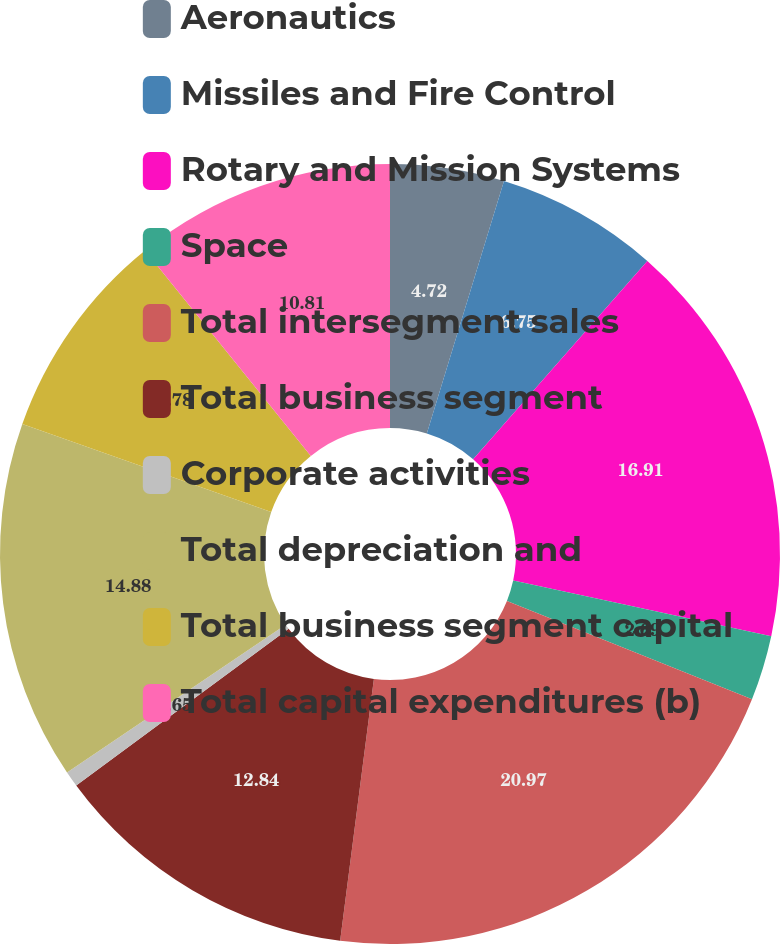<chart> <loc_0><loc_0><loc_500><loc_500><pie_chart><fcel>Aeronautics<fcel>Missiles and Fire Control<fcel>Rotary and Mission Systems<fcel>Space<fcel>Total intersegment sales<fcel>Total business segment<fcel>Corporate activities<fcel>Total depreciation and<fcel>Total business segment capital<fcel>Total capital expenditures (b)<nl><fcel>4.72%<fcel>6.75%<fcel>16.91%<fcel>2.69%<fcel>20.97%<fcel>12.84%<fcel>0.65%<fcel>14.88%<fcel>8.78%<fcel>10.81%<nl></chart> 